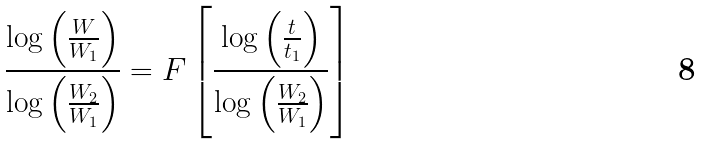Convert formula to latex. <formula><loc_0><loc_0><loc_500><loc_500>\frac { \log \left ( \frac { W } { W _ { 1 } } \right ) } { \log \left ( \frac { W _ { 2 } } { W _ { 1 } } \right ) } = F \left [ \frac { \log \left ( \frac { t } { t _ { 1 } } \right ) } { \log \left ( \frac { W _ { 2 } } { W _ { 1 } } \right ) } \right ]</formula> 